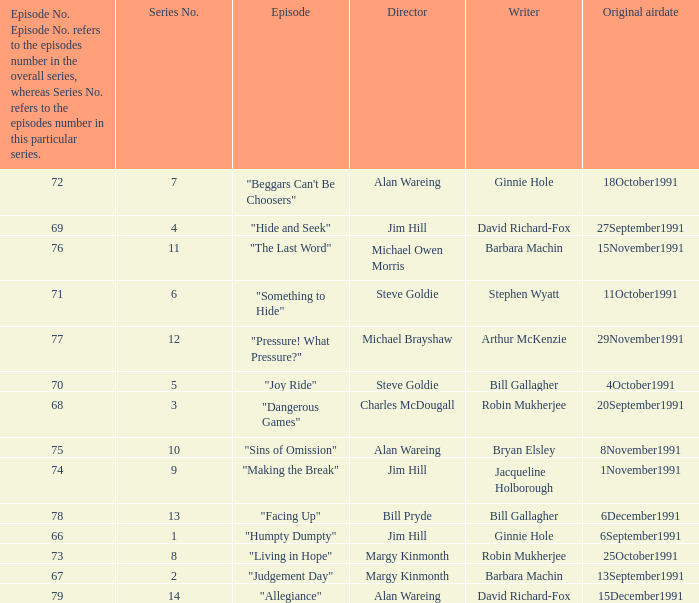Name the least series number for episode number being 78 13.0. 